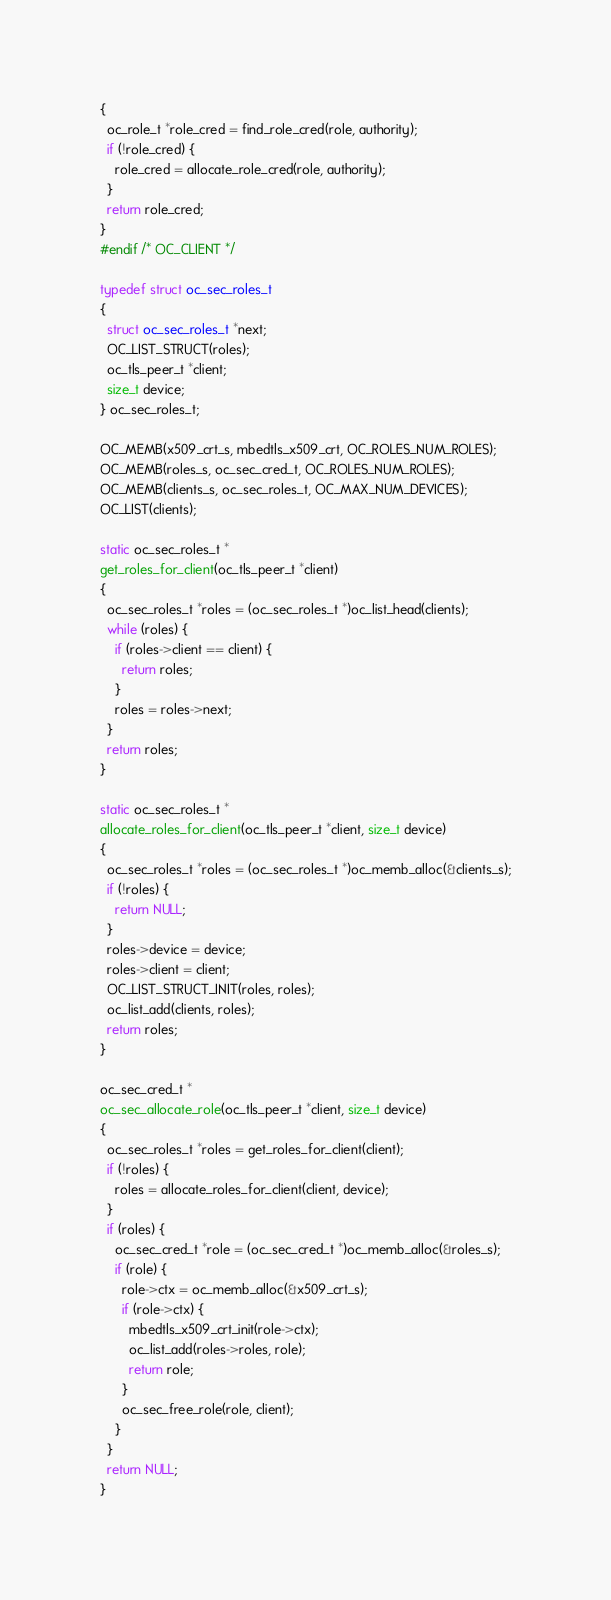Convert code to text. <code><loc_0><loc_0><loc_500><loc_500><_C_>{
  oc_role_t *role_cred = find_role_cred(role, authority);
  if (!role_cred) {
    role_cred = allocate_role_cred(role, authority);
  }
  return role_cred;
}
#endif /* OC_CLIENT */

typedef struct oc_sec_roles_t
{
  struct oc_sec_roles_t *next;
  OC_LIST_STRUCT(roles);
  oc_tls_peer_t *client;
  size_t device;
} oc_sec_roles_t;

OC_MEMB(x509_crt_s, mbedtls_x509_crt, OC_ROLES_NUM_ROLES);
OC_MEMB(roles_s, oc_sec_cred_t, OC_ROLES_NUM_ROLES);
OC_MEMB(clients_s, oc_sec_roles_t, OC_MAX_NUM_DEVICES);
OC_LIST(clients);

static oc_sec_roles_t *
get_roles_for_client(oc_tls_peer_t *client)
{
  oc_sec_roles_t *roles = (oc_sec_roles_t *)oc_list_head(clients);
  while (roles) {
    if (roles->client == client) {
      return roles;
    }
    roles = roles->next;
  }
  return roles;
}

static oc_sec_roles_t *
allocate_roles_for_client(oc_tls_peer_t *client, size_t device)
{
  oc_sec_roles_t *roles = (oc_sec_roles_t *)oc_memb_alloc(&clients_s);
  if (!roles) {
    return NULL;
  }
  roles->device = device;
  roles->client = client;
  OC_LIST_STRUCT_INIT(roles, roles);
  oc_list_add(clients, roles);
  return roles;
}

oc_sec_cred_t *
oc_sec_allocate_role(oc_tls_peer_t *client, size_t device)
{
  oc_sec_roles_t *roles = get_roles_for_client(client);
  if (!roles) {
    roles = allocate_roles_for_client(client, device);
  }
  if (roles) {
    oc_sec_cred_t *role = (oc_sec_cred_t *)oc_memb_alloc(&roles_s);
    if (role) {
      role->ctx = oc_memb_alloc(&x509_crt_s);
      if (role->ctx) {
        mbedtls_x509_crt_init(role->ctx);
        oc_list_add(roles->roles, role);
        return role;
      }
      oc_sec_free_role(role, client);
    }
  }
  return NULL;
}
</code> 